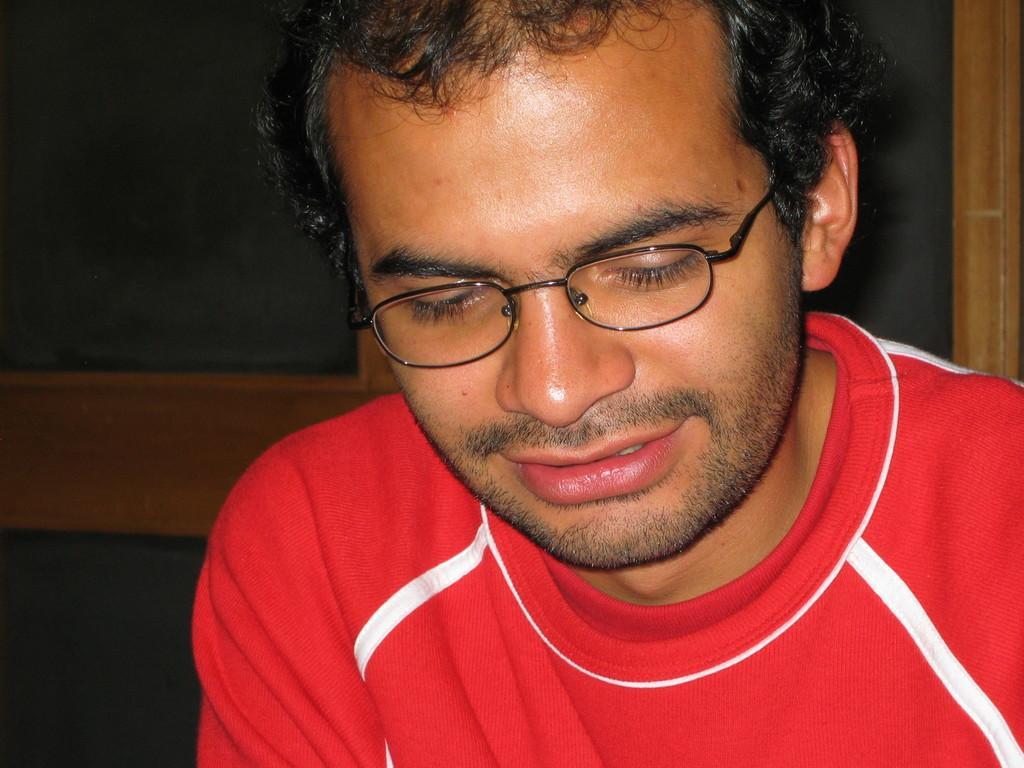Can you describe this image briefly? In this picture there is a person wearing red color T-shirt is having spectacles and there are some other objects behind him. 